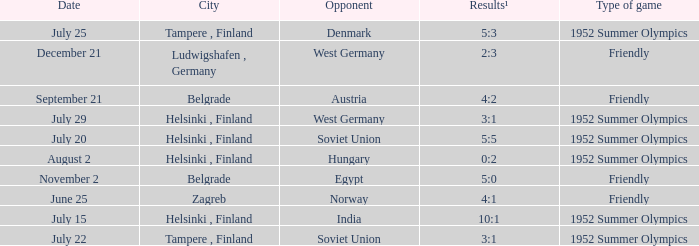What is the name of the City with December 21 as a Date? Ludwigshafen , Germany. 